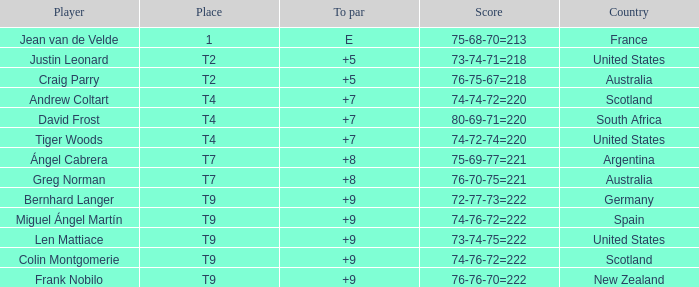Which player from Scotland has a To Par score of +7? Andrew Coltart. 